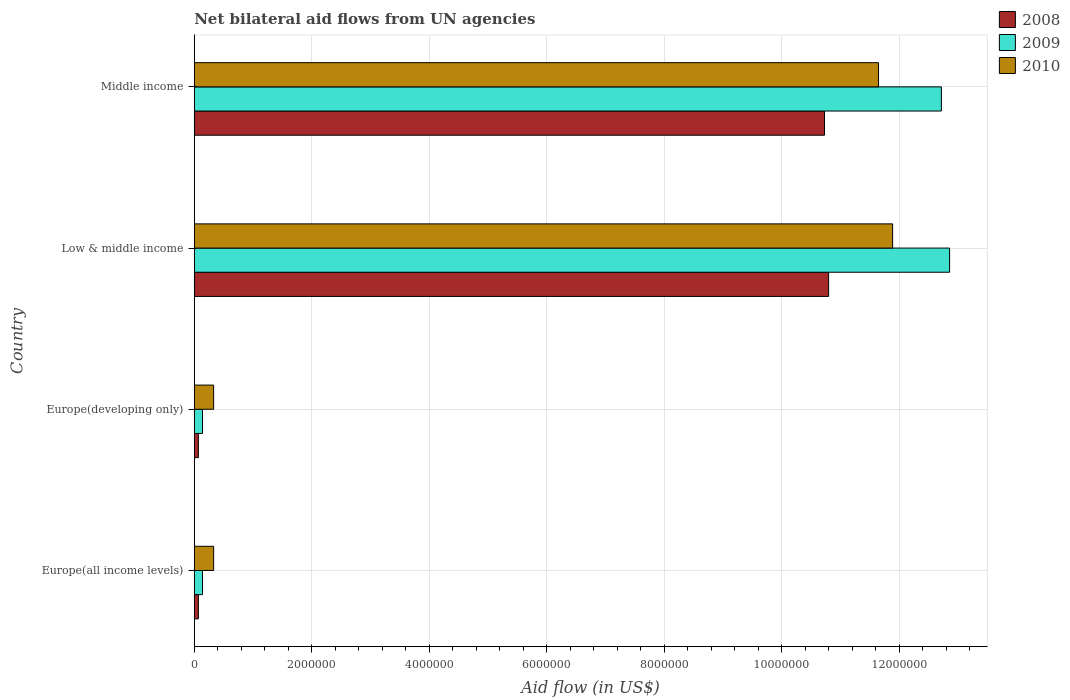How many groups of bars are there?
Offer a terse response. 4. Are the number of bars per tick equal to the number of legend labels?
Make the answer very short. Yes. Are the number of bars on each tick of the Y-axis equal?
Your response must be concise. Yes. Across all countries, what is the maximum net bilateral aid flow in 2010?
Give a very brief answer. 1.19e+07. Across all countries, what is the minimum net bilateral aid flow in 2009?
Give a very brief answer. 1.40e+05. In which country was the net bilateral aid flow in 2008 maximum?
Make the answer very short. Low & middle income. In which country was the net bilateral aid flow in 2008 minimum?
Your response must be concise. Europe(all income levels). What is the total net bilateral aid flow in 2009 in the graph?
Keep it short and to the point. 2.59e+07. What is the difference between the net bilateral aid flow in 2010 in Europe(all income levels) and that in Low & middle income?
Make the answer very short. -1.16e+07. What is the difference between the net bilateral aid flow in 2009 in Middle income and the net bilateral aid flow in 2008 in Low & middle income?
Your answer should be very brief. 1.92e+06. What is the average net bilateral aid flow in 2008 per country?
Give a very brief answer. 5.42e+06. What is the ratio of the net bilateral aid flow in 2010 in Europe(developing only) to that in Low & middle income?
Make the answer very short. 0.03. Is the net bilateral aid flow in 2008 in Europe(all income levels) less than that in Middle income?
Offer a very short reply. Yes. What is the difference between the highest and the lowest net bilateral aid flow in 2009?
Provide a short and direct response. 1.27e+07. Is it the case that in every country, the sum of the net bilateral aid flow in 2009 and net bilateral aid flow in 2010 is greater than the net bilateral aid flow in 2008?
Your answer should be very brief. Yes. Are all the bars in the graph horizontal?
Provide a short and direct response. Yes. Are the values on the major ticks of X-axis written in scientific E-notation?
Make the answer very short. No. Does the graph contain any zero values?
Provide a succinct answer. No. Does the graph contain grids?
Your answer should be very brief. Yes. How many legend labels are there?
Keep it short and to the point. 3. How are the legend labels stacked?
Make the answer very short. Vertical. What is the title of the graph?
Provide a succinct answer. Net bilateral aid flows from UN agencies. What is the label or title of the X-axis?
Provide a short and direct response. Aid flow (in US$). What is the label or title of the Y-axis?
Make the answer very short. Country. What is the Aid flow (in US$) in 2008 in Europe(all income levels)?
Give a very brief answer. 7.00e+04. What is the Aid flow (in US$) in 2009 in Europe(all income levels)?
Make the answer very short. 1.40e+05. What is the Aid flow (in US$) of 2010 in Europe(all income levels)?
Your answer should be very brief. 3.30e+05. What is the Aid flow (in US$) of 2008 in Europe(developing only)?
Give a very brief answer. 7.00e+04. What is the Aid flow (in US$) of 2009 in Europe(developing only)?
Your answer should be very brief. 1.40e+05. What is the Aid flow (in US$) in 2008 in Low & middle income?
Ensure brevity in your answer.  1.08e+07. What is the Aid flow (in US$) in 2009 in Low & middle income?
Offer a terse response. 1.29e+07. What is the Aid flow (in US$) of 2010 in Low & middle income?
Make the answer very short. 1.19e+07. What is the Aid flow (in US$) in 2008 in Middle income?
Provide a short and direct response. 1.07e+07. What is the Aid flow (in US$) in 2009 in Middle income?
Ensure brevity in your answer.  1.27e+07. What is the Aid flow (in US$) in 2010 in Middle income?
Provide a short and direct response. 1.16e+07. Across all countries, what is the maximum Aid flow (in US$) in 2008?
Offer a terse response. 1.08e+07. Across all countries, what is the maximum Aid flow (in US$) in 2009?
Provide a succinct answer. 1.29e+07. Across all countries, what is the maximum Aid flow (in US$) of 2010?
Offer a very short reply. 1.19e+07. Across all countries, what is the minimum Aid flow (in US$) of 2009?
Ensure brevity in your answer.  1.40e+05. What is the total Aid flow (in US$) of 2008 in the graph?
Your answer should be compact. 2.17e+07. What is the total Aid flow (in US$) in 2009 in the graph?
Make the answer very short. 2.59e+07. What is the total Aid flow (in US$) of 2010 in the graph?
Offer a terse response. 2.42e+07. What is the difference between the Aid flow (in US$) of 2008 in Europe(all income levels) and that in Europe(developing only)?
Your response must be concise. 0. What is the difference between the Aid flow (in US$) in 2010 in Europe(all income levels) and that in Europe(developing only)?
Your response must be concise. 0. What is the difference between the Aid flow (in US$) of 2008 in Europe(all income levels) and that in Low & middle income?
Make the answer very short. -1.07e+07. What is the difference between the Aid flow (in US$) of 2009 in Europe(all income levels) and that in Low & middle income?
Make the answer very short. -1.27e+07. What is the difference between the Aid flow (in US$) in 2010 in Europe(all income levels) and that in Low & middle income?
Provide a succinct answer. -1.16e+07. What is the difference between the Aid flow (in US$) in 2008 in Europe(all income levels) and that in Middle income?
Provide a succinct answer. -1.07e+07. What is the difference between the Aid flow (in US$) of 2009 in Europe(all income levels) and that in Middle income?
Give a very brief answer. -1.26e+07. What is the difference between the Aid flow (in US$) of 2010 in Europe(all income levels) and that in Middle income?
Provide a succinct answer. -1.13e+07. What is the difference between the Aid flow (in US$) of 2008 in Europe(developing only) and that in Low & middle income?
Offer a very short reply. -1.07e+07. What is the difference between the Aid flow (in US$) in 2009 in Europe(developing only) and that in Low & middle income?
Offer a terse response. -1.27e+07. What is the difference between the Aid flow (in US$) of 2010 in Europe(developing only) and that in Low & middle income?
Your response must be concise. -1.16e+07. What is the difference between the Aid flow (in US$) in 2008 in Europe(developing only) and that in Middle income?
Provide a short and direct response. -1.07e+07. What is the difference between the Aid flow (in US$) in 2009 in Europe(developing only) and that in Middle income?
Keep it short and to the point. -1.26e+07. What is the difference between the Aid flow (in US$) of 2010 in Europe(developing only) and that in Middle income?
Provide a short and direct response. -1.13e+07. What is the difference between the Aid flow (in US$) of 2008 in Low & middle income and that in Middle income?
Give a very brief answer. 7.00e+04. What is the difference between the Aid flow (in US$) of 2009 in Low & middle income and that in Middle income?
Offer a very short reply. 1.40e+05. What is the difference between the Aid flow (in US$) of 2009 in Europe(all income levels) and the Aid flow (in US$) of 2010 in Europe(developing only)?
Give a very brief answer. -1.90e+05. What is the difference between the Aid flow (in US$) in 2008 in Europe(all income levels) and the Aid flow (in US$) in 2009 in Low & middle income?
Your answer should be very brief. -1.28e+07. What is the difference between the Aid flow (in US$) in 2008 in Europe(all income levels) and the Aid flow (in US$) in 2010 in Low & middle income?
Give a very brief answer. -1.18e+07. What is the difference between the Aid flow (in US$) in 2009 in Europe(all income levels) and the Aid flow (in US$) in 2010 in Low & middle income?
Your answer should be very brief. -1.18e+07. What is the difference between the Aid flow (in US$) in 2008 in Europe(all income levels) and the Aid flow (in US$) in 2009 in Middle income?
Offer a very short reply. -1.26e+07. What is the difference between the Aid flow (in US$) in 2008 in Europe(all income levels) and the Aid flow (in US$) in 2010 in Middle income?
Your answer should be compact. -1.16e+07. What is the difference between the Aid flow (in US$) of 2009 in Europe(all income levels) and the Aid flow (in US$) of 2010 in Middle income?
Offer a terse response. -1.15e+07. What is the difference between the Aid flow (in US$) of 2008 in Europe(developing only) and the Aid flow (in US$) of 2009 in Low & middle income?
Your answer should be very brief. -1.28e+07. What is the difference between the Aid flow (in US$) in 2008 in Europe(developing only) and the Aid flow (in US$) in 2010 in Low & middle income?
Your response must be concise. -1.18e+07. What is the difference between the Aid flow (in US$) of 2009 in Europe(developing only) and the Aid flow (in US$) of 2010 in Low & middle income?
Give a very brief answer. -1.18e+07. What is the difference between the Aid flow (in US$) in 2008 in Europe(developing only) and the Aid flow (in US$) in 2009 in Middle income?
Offer a very short reply. -1.26e+07. What is the difference between the Aid flow (in US$) of 2008 in Europe(developing only) and the Aid flow (in US$) of 2010 in Middle income?
Your answer should be compact. -1.16e+07. What is the difference between the Aid flow (in US$) of 2009 in Europe(developing only) and the Aid flow (in US$) of 2010 in Middle income?
Make the answer very short. -1.15e+07. What is the difference between the Aid flow (in US$) of 2008 in Low & middle income and the Aid flow (in US$) of 2009 in Middle income?
Offer a terse response. -1.92e+06. What is the difference between the Aid flow (in US$) of 2008 in Low & middle income and the Aid flow (in US$) of 2010 in Middle income?
Ensure brevity in your answer.  -8.50e+05. What is the difference between the Aid flow (in US$) of 2009 in Low & middle income and the Aid flow (in US$) of 2010 in Middle income?
Your answer should be very brief. 1.21e+06. What is the average Aid flow (in US$) of 2008 per country?
Give a very brief answer. 5.42e+06. What is the average Aid flow (in US$) of 2009 per country?
Make the answer very short. 6.46e+06. What is the average Aid flow (in US$) in 2010 per country?
Make the answer very short. 6.05e+06. What is the difference between the Aid flow (in US$) of 2008 and Aid flow (in US$) of 2009 in Europe(all income levels)?
Your answer should be compact. -7.00e+04. What is the difference between the Aid flow (in US$) in 2008 and Aid flow (in US$) in 2010 in Europe(all income levels)?
Your response must be concise. -2.60e+05. What is the difference between the Aid flow (in US$) of 2008 and Aid flow (in US$) of 2009 in Europe(developing only)?
Give a very brief answer. -7.00e+04. What is the difference between the Aid flow (in US$) in 2009 and Aid flow (in US$) in 2010 in Europe(developing only)?
Ensure brevity in your answer.  -1.90e+05. What is the difference between the Aid flow (in US$) of 2008 and Aid flow (in US$) of 2009 in Low & middle income?
Give a very brief answer. -2.06e+06. What is the difference between the Aid flow (in US$) of 2008 and Aid flow (in US$) of 2010 in Low & middle income?
Make the answer very short. -1.09e+06. What is the difference between the Aid flow (in US$) of 2009 and Aid flow (in US$) of 2010 in Low & middle income?
Provide a succinct answer. 9.70e+05. What is the difference between the Aid flow (in US$) of 2008 and Aid flow (in US$) of 2009 in Middle income?
Offer a terse response. -1.99e+06. What is the difference between the Aid flow (in US$) of 2008 and Aid flow (in US$) of 2010 in Middle income?
Offer a very short reply. -9.20e+05. What is the difference between the Aid flow (in US$) in 2009 and Aid flow (in US$) in 2010 in Middle income?
Provide a short and direct response. 1.07e+06. What is the ratio of the Aid flow (in US$) in 2008 in Europe(all income levels) to that in Europe(developing only)?
Give a very brief answer. 1. What is the ratio of the Aid flow (in US$) of 2008 in Europe(all income levels) to that in Low & middle income?
Provide a short and direct response. 0.01. What is the ratio of the Aid flow (in US$) of 2009 in Europe(all income levels) to that in Low & middle income?
Keep it short and to the point. 0.01. What is the ratio of the Aid flow (in US$) of 2010 in Europe(all income levels) to that in Low & middle income?
Ensure brevity in your answer.  0.03. What is the ratio of the Aid flow (in US$) of 2008 in Europe(all income levels) to that in Middle income?
Offer a terse response. 0.01. What is the ratio of the Aid flow (in US$) in 2009 in Europe(all income levels) to that in Middle income?
Keep it short and to the point. 0.01. What is the ratio of the Aid flow (in US$) of 2010 in Europe(all income levels) to that in Middle income?
Keep it short and to the point. 0.03. What is the ratio of the Aid flow (in US$) of 2008 in Europe(developing only) to that in Low & middle income?
Ensure brevity in your answer.  0.01. What is the ratio of the Aid flow (in US$) of 2009 in Europe(developing only) to that in Low & middle income?
Offer a terse response. 0.01. What is the ratio of the Aid flow (in US$) of 2010 in Europe(developing only) to that in Low & middle income?
Offer a very short reply. 0.03. What is the ratio of the Aid flow (in US$) of 2008 in Europe(developing only) to that in Middle income?
Make the answer very short. 0.01. What is the ratio of the Aid flow (in US$) in 2009 in Europe(developing only) to that in Middle income?
Make the answer very short. 0.01. What is the ratio of the Aid flow (in US$) in 2010 in Europe(developing only) to that in Middle income?
Ensure brevity in your answer.  0.03. What is the ratio of the Aid flow (in US$) of 2008 in Low & middle income to that in Middle income?
Ensure brevity in your answer.  1.01. What is the ratio of the Aid flow (in US$) in 2010 in Low & middle income to that in Middle income?
Your answer should be very brief. 1.02. What is the difference between the highest and the second highest Aid flow (in US$) in 2008?
Provide a succinct answer. 7.00e+04. What is the difference between the highest and the second highest Aid flow (in US$) of 2010?
Offer a very short reply. 2.40e+05. What is the difference between the highest and the lowest Aid flow (in US$) of 2008?
Give a very brief answer. 1.07e+07. What is the difference between the highest and the lowest Aid flow (in US$) in 2009?
Your answer should be compact. 1.27e+07. What is the difference between the highest and the lowest Aid flow (in US$) of 2010?
Keep it short and to the point. 1.16e+07. 